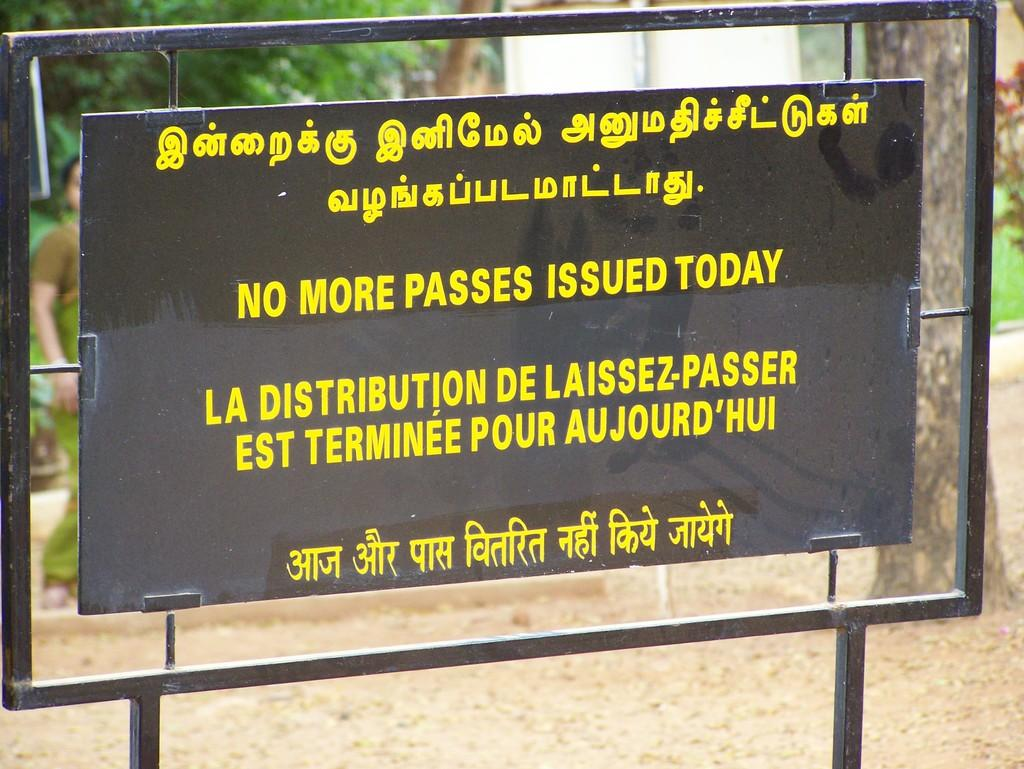<image>
Present a compact description of the photo's key features. A black sign states that no more passes will be issued today in yellow writing. 